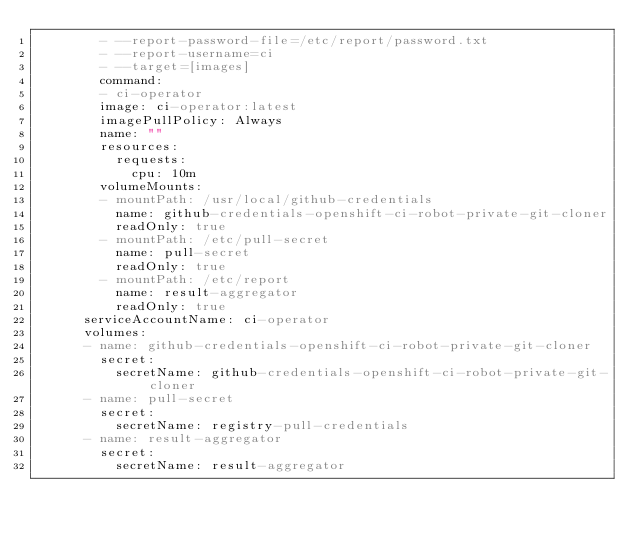<code> <loc_0><loc_0><loc_500><loc_500><_YAML_>        - --report-password-file=/etc/report/password.txt
        - --report-username=ci
        - --target=[images]
        command:
        - ci-operator
        image: ci-operator:latest
        imagePullPolicy: Always
        name: ""
        resources:
          requests:
            cpu: 10m
        volumeMounts:
        - mountPath: /usr/local/github-credentials
          name: github-credentials-openshift-ci-robot-private-git-cloner
          readOnly: true
        - mountPath: /etc/pull-secret
          name: pull-secret
          readOnly: true
        - mountPath: /etc/report
          name: result-aggregator
          readOnly: true
      serviceAccountName: ci-operator
      volumes:
      - name: github-credentials-openshift-ci-robot-private-git-cloner
        secret:
          secretName: github-credentials-openshift-ci-robot-private-git-cloner
      - name: pull-secret
        secret:
          secretName: registry-pull-credentials
      - name: result-aggregator
        secret:
          secretName: result-aggregator
</code> 